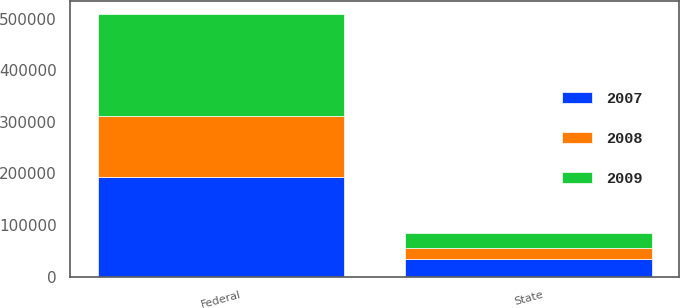<chart> <loc_0><loc_0><loc_500><loc_500><stacked_bar_chart><ecel><fcel>Federal<fcel>State<nl><fcel>2007<fcel>193181<fcel>34415<nl><fcel>2008<fcel>118764<fcel>20595<nl><fcel>2009<fcel>196556<fcel>30424<nl></chart> 